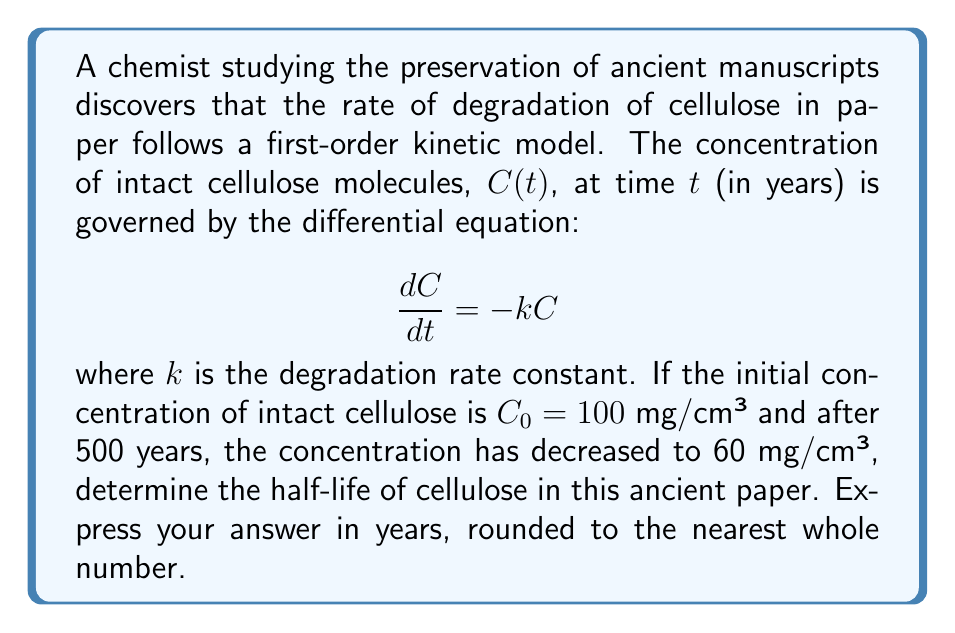What is the answer to this math problem? To solve this problem, we'll follow these steps:

1) The general solution to the first-order differential equation $\frac{dC}{dt} = -kC$ is:

   $$C(t) = C_0e^{-kt}$$

2) We're given that $C_0 = 100$ mg/cm³ and after 500 years, $C(500) = 60$ mg/cm³. Let's substitute these values:

   $$60 = 100e^{-500k}$$

3) Dividing both sides by 100:

   $$0.6 = e^{-500k}$$

4) Taking the natural logarithm of both sides:

   $$\ln(0.6) = -500k$$

5) Solving for $k$:

   $$k = -\frac{\ln(0.6)}{500} \approx 0.001022 \text{ year}^{-1}$$

6) The half-life $t_{1/2}$ is the time it takes for the concentration to decrease to half its original value. It's given by:

   $$t_{1/2} = \frac{\ln(2)}{k}$$

7) Substituting our value for $k$:

   $$t_{1/2} = \frac{\ln(2)}{0.001022} \approx 678.3 \text{ years}$$

8) Rounding to the nearest whole number:

   $$t_{1/2} \approx 678 \text{ years}$$
Answer: 678 years 